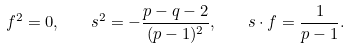<formula> <loc_0><loc_0><loc_500><loc_500>f ^ { 2 } = 0 , \quad s ^ { 2 } = - \frac { p - q - 2 } { ( p - 1 ) ^ { 2 } } , \quad s \cdot f = \frac { 1 } { p - 1 } .</formula> 